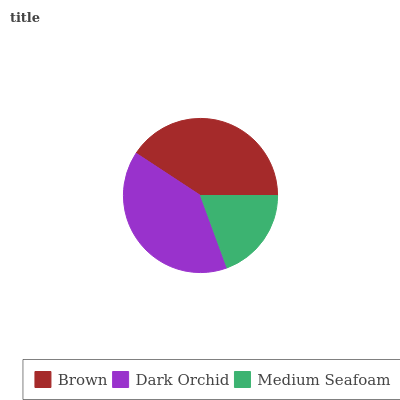Is Medium Seafoam the minimum?
Answer yes or no. Yes. Is Brown the maximum?
Answer yes or no. Yes. Is Dark Orchid the minimum?
Answer yes or no. No. Is Dark Orchid the maximum?
Answer yes or no. No. Is Brown greater than Dark Orchid?
Answer yes or no. Yes. Is Dark Orchid less than Brown?
Answer yes or no. Yes. Is Dark Orchid greater than Brown?
Answer yes or no. No. Is Brown less than Dark Orchid?
Answer yes or no. No. Is Dark Orchid the high median?
Answer yes or no. Yes. Is Dark Orchid the low median?
Answer yes or no. Yes. Is Brown the high median?
Answer yes or no. No. Is Medium Seafoam the low median?
Answer yes or no. No. 